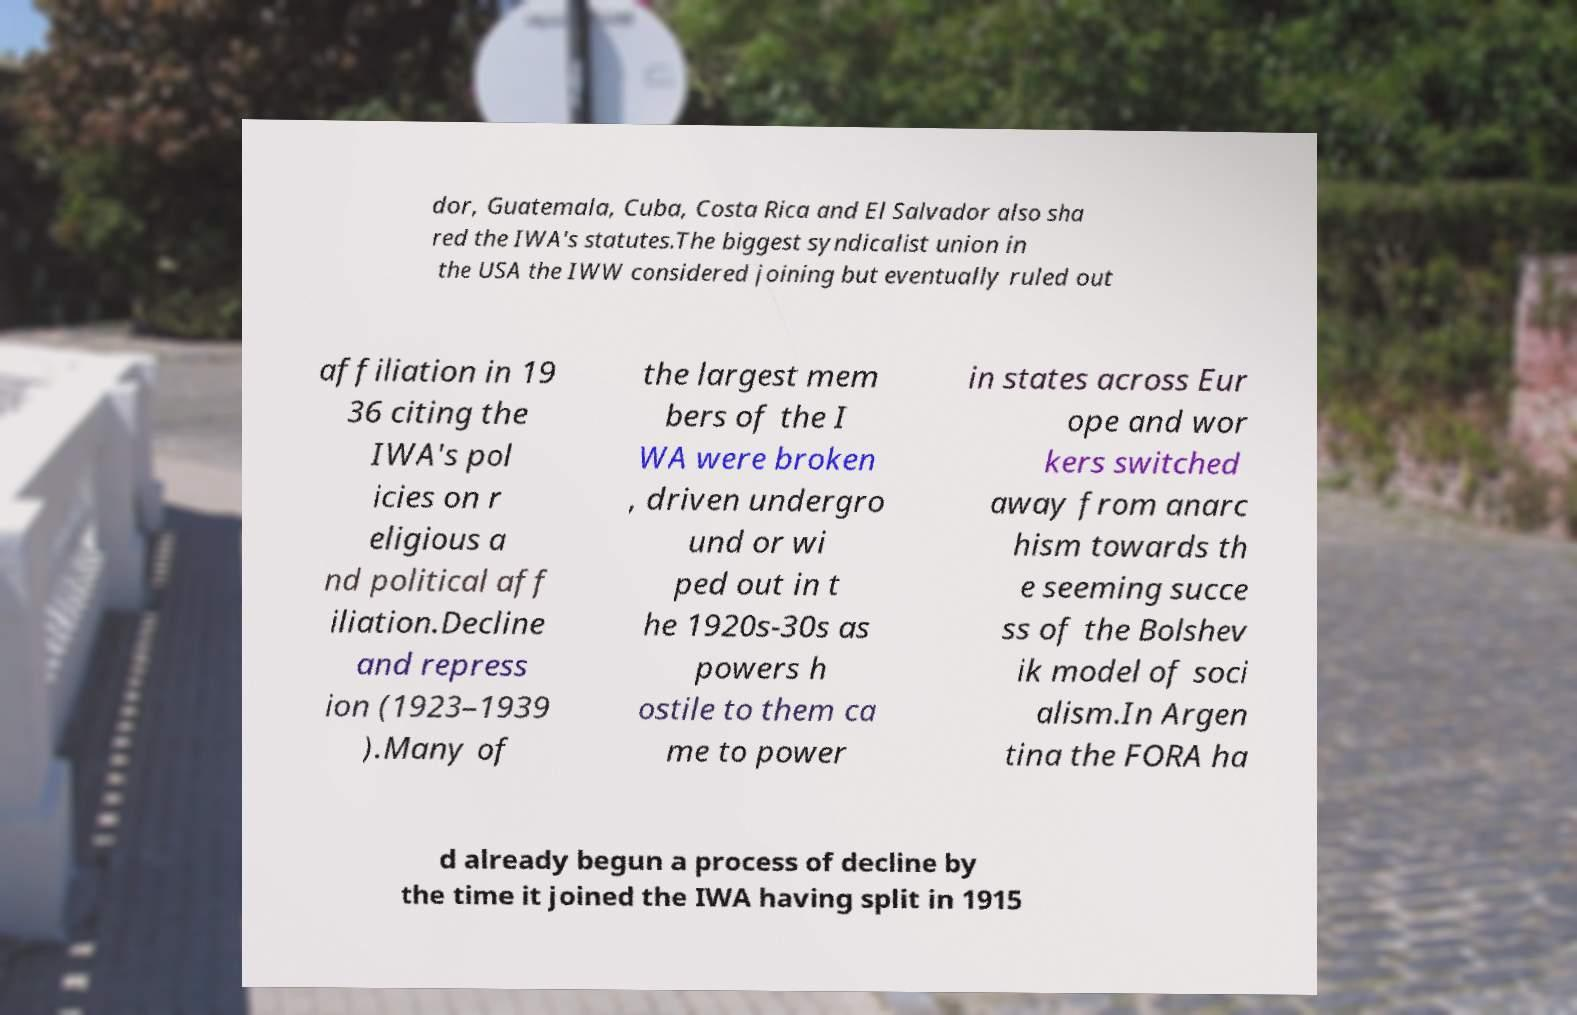For documentation purposes, I need the text within this image transcribed. Could you provide that? dor, Guatemala, Cuba, Costa Rica and El Salvador also sha red the IWA's statutes.The biggest syndicalist union in the USA the IWW considered joining but eventually ruled out affiliation in 19 36 citing the IWA's pol icies on r eligious a nd political aff iliation.Decline and repress ion (1923–1939 ).Many of the largest mem bers of the I WA were broken , driven undergro und or wi ped out in t he 1920s-30s as powers h ostile to them ca me to power in states across Eur ope and wor kers switched away from anarc hism towards th e seeming succe ss of the Bolshev ik model of soci alism.In Argen tina the FORA ha d already begun a process of decline by the time it joined the IWA having split in 1915 